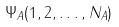<formula> <loc_0><loc_0><loc_500><loc_500>\Psi _ { A } ( 1 , 2 , \dots , N _ { A } )</formula> 